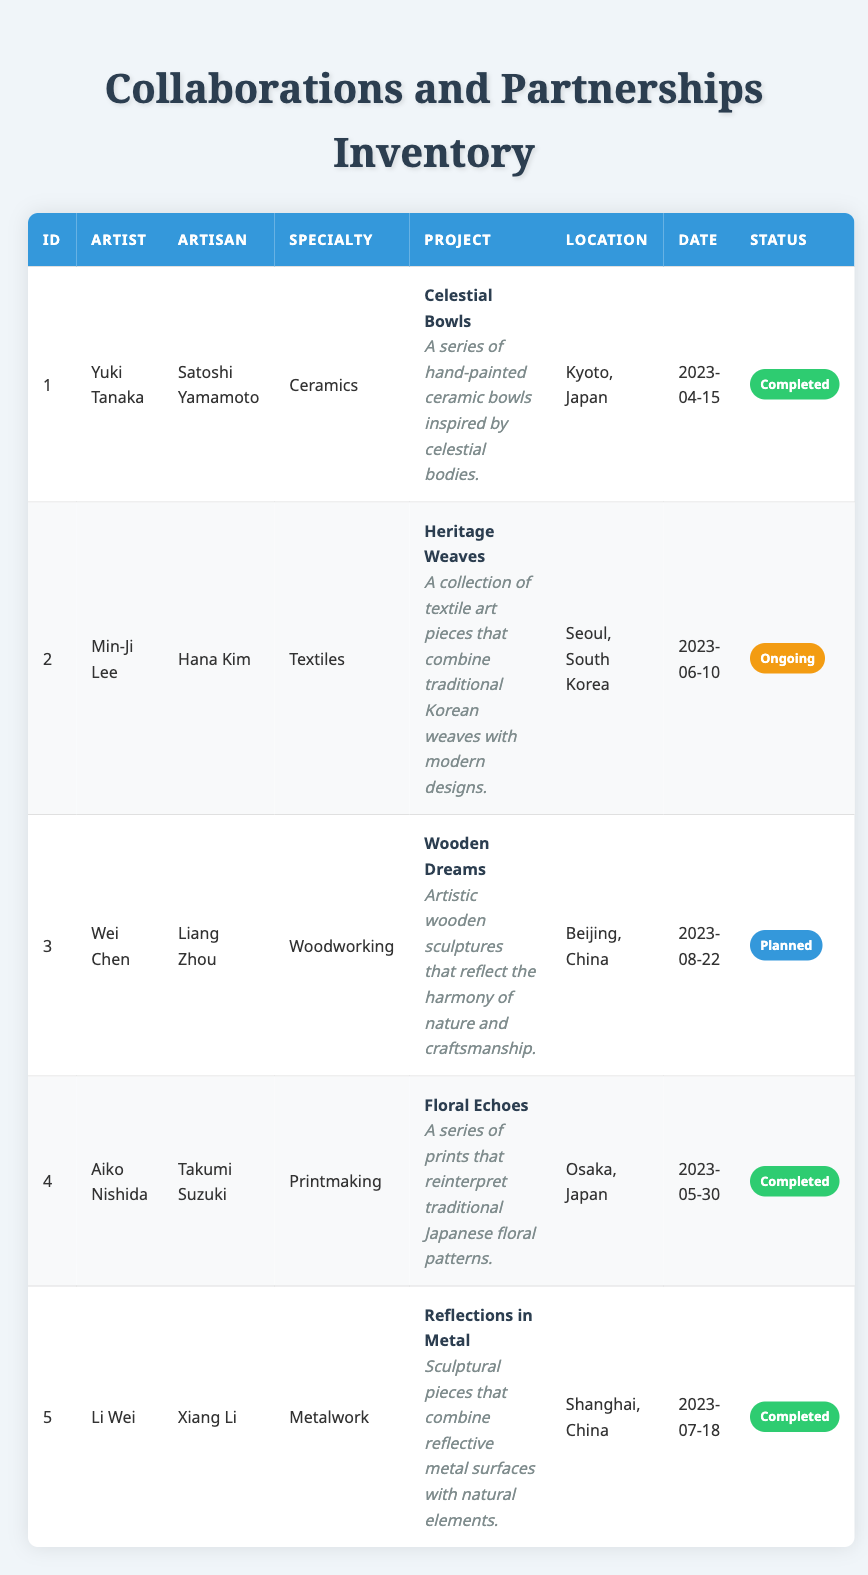What is the project title for the collaboration between Yuki Tanaka and Satoshi Yamamoto? The project title is listed in the table under the "Project" column for their collaboration entry, which is "Celestial Bowls."
Answer: Celestial Bowls Which artisan specializes in ceramics? The "artisan_specialty" column identifies the specialty of each artisan. The entry for Satoshi Yamamoto indicates he specializes in ceramics.
Answer: Satoshi Yamamoto How many collaborations are listed as completed? Count the entries under the status column that say "Completed." There are 3 entries marked as completed: collaborations 1, 4, and 5.
Answer: 3 What is the artisan's name associated with the project "Heritage Weaves"? Look in the table for the project title "Heritage Weaves," which is in the entry for Min-Ji Lee. The associated artisan's name is Hana Kim.
Answer: Hana Kim Are there any collaborations that are planned for the year 2023? Check the status of each collaboration listed. Only collaboration 3 (Wei Chen and Liang Zhou) has a status of "Planned," which answers the question positively.
Answer: Yes Which location has the most collaborations? Count the number of collaborations associated with each location. Kyoto has 1, Seoul has 1, Beijing has 1, Osaka has 1, and Shanghai has 1—none is repeated. Therefore, no location has more than 1 collaboration.
Answer: None What is the specialty of the artisan involved in the "Wooden Dreams" project? By locating the entry for "Wooden Dreams" in the table, we see that Liang Zhou is the artisan for this project, and his specialty is woodworking.
Answer: Woodworking List the collaboration date for the project "Floral Echoes." It's possible to find "Floral Echoes" by searching the project titles in the table. The listed collaboration date for this project is "2023-05-30."
Answer: 2023-05-30 How many artists collaborated with artisans specializing in metalwork? Review each entry for the artisan's specialty and count the instances where the specialty is metalwork. There is only one entry that involves an artisan skilled in metalwork, which is Xiang Li.
Answer: 1 